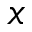Convert formula to latex. <formula><loc_0><loc_0><loc_500><loc_500>x</formula> 